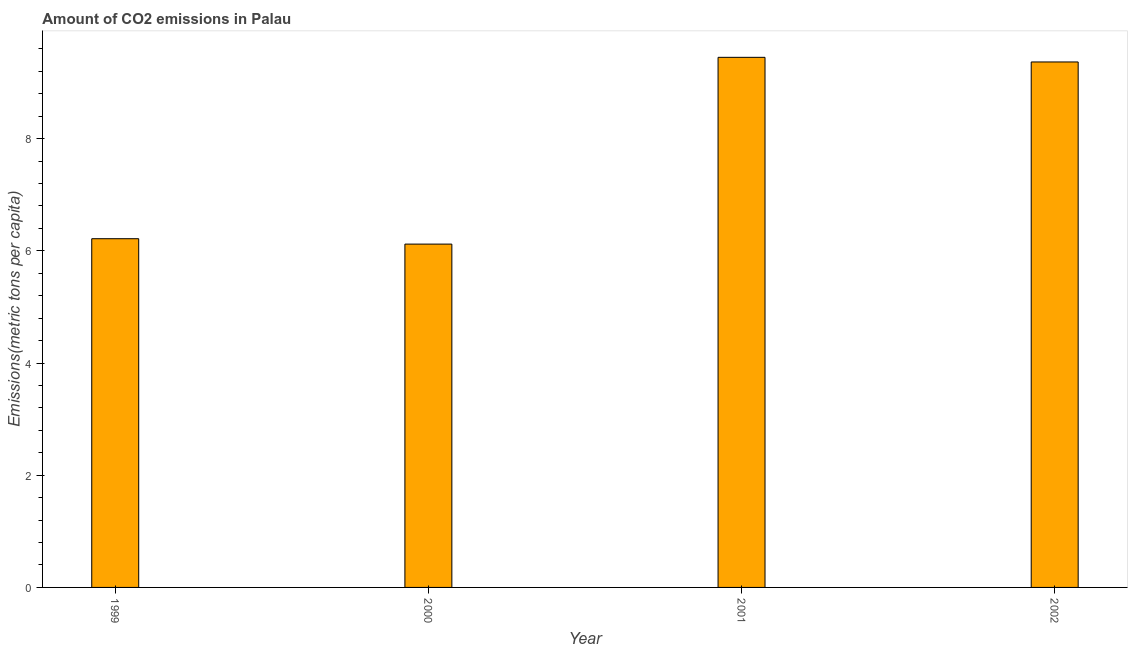Does the graph contain grids?
Your answer should be compact. No. What is the title of the graph?
Keep it short and to the point. Amount of CO2 emissions in Palau. What is the label or title of the Y-axis?
Make the answer very short. Emissions(metric tons per capita). What is the amount of co2 emissions in 2002?
Keep it short and to the point. 9.37. Across all years, what is the maximum amount of co2 emissions?
Make the answer very short. 9.45. Across all years, what is the minimum amount of co2 emissions?
Your response must be concise. 6.12. In which year was the amount of co2 emissions minimum?
Give a very brief answer. 2000. What is the sum of the amount of co2 emissions?
Your response must be concise. 31.15. What is the difference between the amount of co2 emissions in 2000 and 2001?
Offer a very short reply. -3.33. What is the average amount of co2 emissions per year?
Keep it short and to the point. 7.79. What is the median amount of co2 emissions?
Ensure brevity in your answer.  7.79. Do a majority of the years between 1999 and 2000 (inclusive) have amount of co2 emissions greater than 7.6 metric tons per capita?
Provide a short and direct response. No. What is the difference between the highest and the second highest amount of co2 emissions?
Offer a terse response. 0.08. What is the difference between the highest and the lowest amount of co2 emissions?
Make the answer very short. 3.33. How many bars are there?
Keep it short and to the point. 4. Are all the bars in the graph horizontal?
Provide a short and direct response. No. Are the values on the major ticks of Y-axis written in scientific E-notation?
Your answer should be very brief. No. What is the Emissions(metric tons per capita) in 1999?
Give a very brief answer. 6.22. What is the Emissions(metric tons per capita) of 2000?
Your answer should be very brief. 6.12. What is the Emissions(metric tons per capita) in 2001?
Your answer should be compact. 9.45. What is the Emissions(metric tons per capita) of 2002?
Make the answer very short. 9.37. What is the difference between the Emissions(metric tons per capita) in 1999 and 2000?
Give a very brief answer. 0.1. What is the difference between the Emissions(metric tons per capita) in 1999 and 2001?
Keep it short and to the point. -3.23. What is the difference between the Emissions(metric tons per capita) in 1999 and 2002?
Offer a terse response. -3.15. What is the difference between the Emissions(metric tons per capita) in 2000 and 2001?
Your response must be concise. -3.33. What is the difference between the Emissions(metric tons per capita) in 2000 and 2002?
Offer a very short reply. -3.25. What is the difference between the Emissions(metric tons per capita) in 2001 and 2002?
Keep it short and to the point. 0.08. What is the ratio of the Emissions(metric tons per capita) in 1999 to that in 2001?
Your response must be concise. 0.66. What is the ratio of the Emissions(metric tons per capita) in 1999 to that in 2002?
Offer a very short reply. 0.66. What is the ratio of the Emissions(metric tons per capita) in 2000 to that in 2001?
Keep it short and to the point. 0.65. What is the ratio of the Emissions(metric tons per capita) in 2000 to that in 2002?
Provide a succinct answer. 0.65. What is the ratio of the Emissions(metric tons per capita) in 2001 to that in 2002?
Keep it short and to the point. 1.01. 